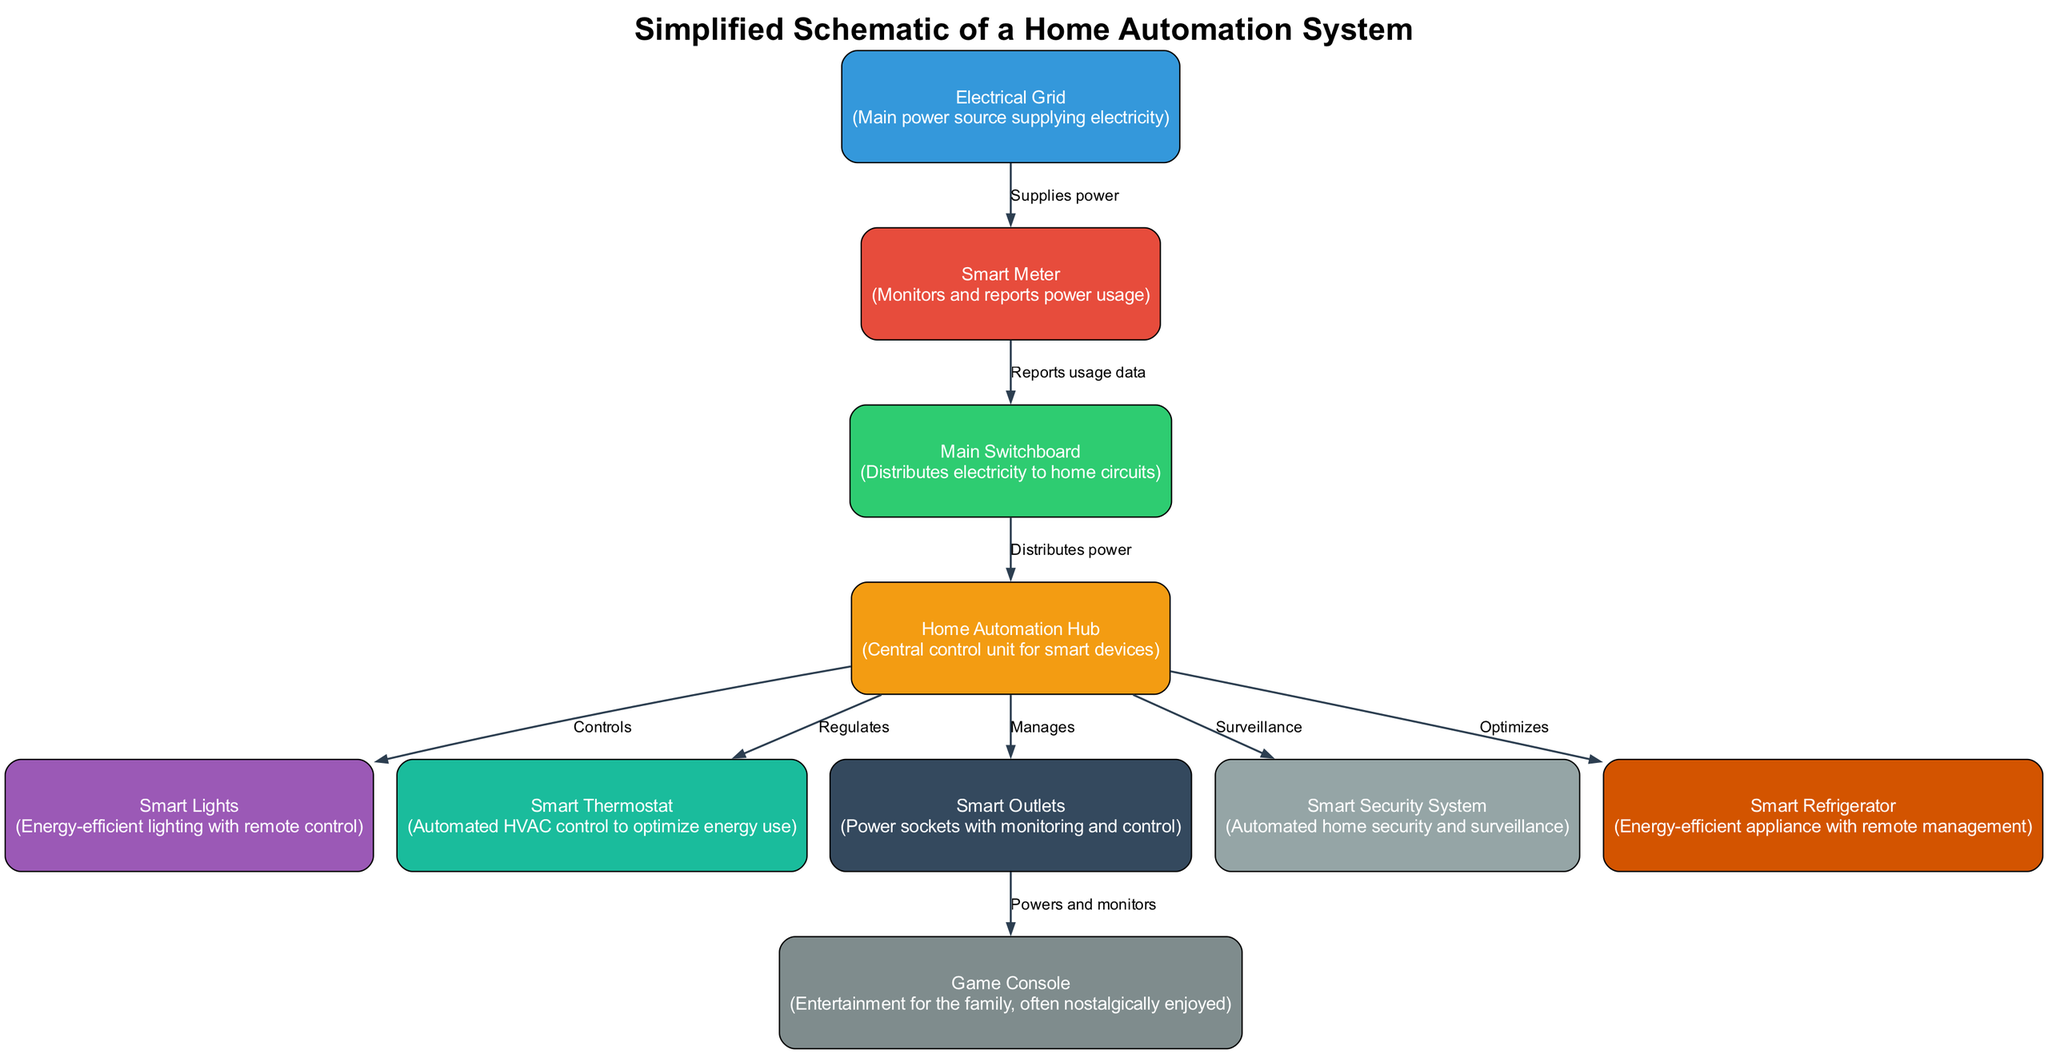What is the main power source supplying electricity? The diagram identifies the node labeled "Electrical Grid" as the main power source that supplies electricity to the system.
Answer: Electrical Grid How many smart devices are directly controlled by the home automation hub? There are five devices mentioned in the diagram that are directly controlled by the hub: smart lights, smart thermostat, smart outlets, smart security system, and smart fridge. Therefore, the count is five.
Answer: Five What does the smart meter report to the main switchboard? The specification in the diagram indicates that the smart meter reports "usage data" to the main switchboard, which allows for monitoring of power consumption.
Answer: Usage data Which device is powered and monitored by smart outlets? The diagram shows that the "Game Console" is the device powered and monitored by the smart outlets, indicating its connection within the home automation system.
Answer: Game Console What is the function of the smart thermostat in the system? According to the diagram, the smart thermostat "automates HVAC control to optimize energy use," indicating its role in heating and cooling efficiency.
Answer: Automates HVAC control How does the electrical grid connect to the smart meter? The diagram illustrates a direct connection where the electrical grid supplies power to the smart meter, indicating the flow of electricity into the monitoring system.
Answer: Supplies power How many total nodes are represented in the diagram? The diagram features eight nodes, including the electrical grid, smart meter, main switchboard, hub, smart lights, smart thermostat, smart outlets, and smart security system.
Answer: Eight Which device does the home automation hub manage that is related to food preservation? The diagram specifies that the "Smart Refrigerator" is managed by the home automation hub, highlighting its role in food preservation and energy optimization.
Answer: Smart Refrigerator What connects the hub to the security system? The edge in the diagram specifically indicates that the hub "surveils" the connection to the smart security system, showcasing how control is established.
Answer: Surveillance 